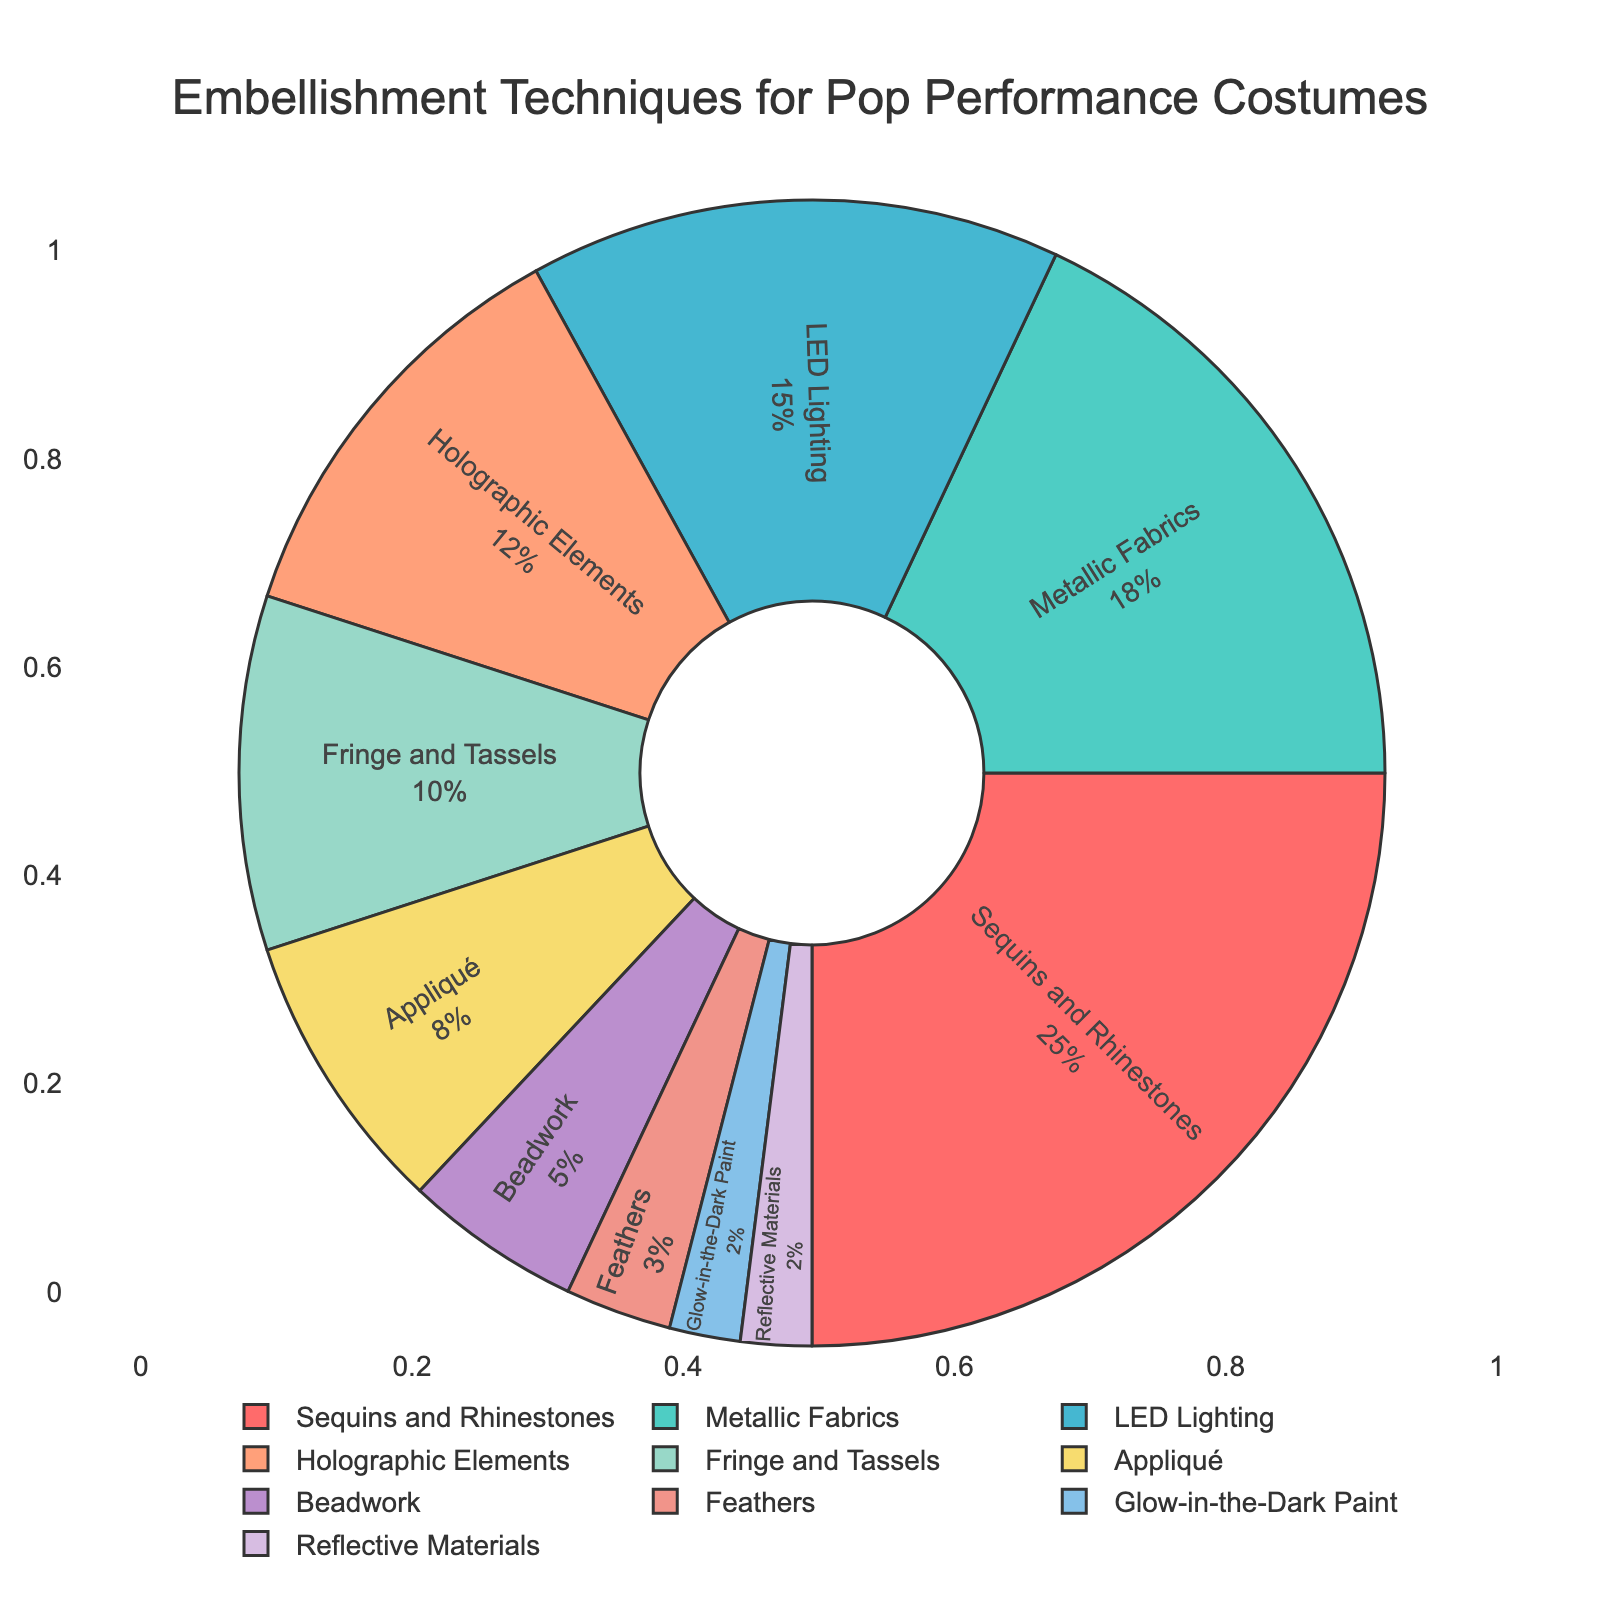What is the total percentage of the top three most used embellishment techniques? The top three embellishment techniques are Sequins and Rhinestones (25%), Metallic Fabrics (18%), and LED Lighting (15%). Adding them together, 25 + 18 + 15 = 58
Answer: 58 Which embellishment technique is used less than Holographic Elements but more than Appliqué? Holographic Elements has 12% and Appliqué has 8%. Fringe and Tassels (10%) are used between these two values
Answer: Fringe and Tassels Compare the usage proportions of Beadwork and Feathers. Which technique is used more and by how much? Beadwork is at 5% and Feathers are at 3%. The difference is calculated as 5 - 3 = 2
Answer: Beadwork, by 2% What percentage of the embellishment techniques combined do Glow-in-the-Dark Paint and Reflective Materials account for? Both Glow-in-the-Dark Paint and Reflective Materials are at 2% each. Adding them together, 2 + 2 = 4
Answer: 4 What are the embellishment techniques represented by shades of blue in the pie chart? The two shades of blue in the chart correspond to Metallic Fabrics and LED Lighting
Answer: Metallic Fabrics and LED Lighting By how much does the percentage of Sequins and Rhinestones exceed that of Appliqué? Sequins and Rhinestones are at 25%, while Appliqué is at 8%. The difference is calculated as 25 - 8 = 17
Answer: 17 What is the second least used embellishment technique? The least used technique is Glow-in-the-Dark Paint and Reflective Materials (each at 2%). The second least used is Feathers at 3%
Answer: Feathers Which technique has a higher percentage, Holographic Elements or Fringe and Tassels, and by how much? Holographic Elements are at 12% and Fringe and Tassels are at 10%. The difference is calculated as 12 - 10 = 2
Answer: Holographic Elements, by 2% Identify the embellishment technique used the least and state its percentage. Both Glow-in-the-Dark Paint and Reflective Materials are the least used techniques, each with a percentage of 2%
Answer: Glow-in-the-Dark Paint and Reflective Materials, 2% How does the usage of Metallic Fabrics compare to the combined usage of Beadwork and Feathers? Metallic Fabrics are at 18%, while Beadwork is at 5% and Feathers at 3%. Combining Beadwork and Feathers, 5 + 3 = 8. Comparing 18 to 8 shows Metallic Fabrics are used more by 18 - 8 = 10
Answer: Metallic Fabrics, by 10% 